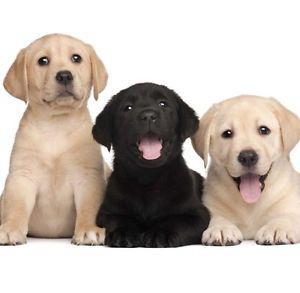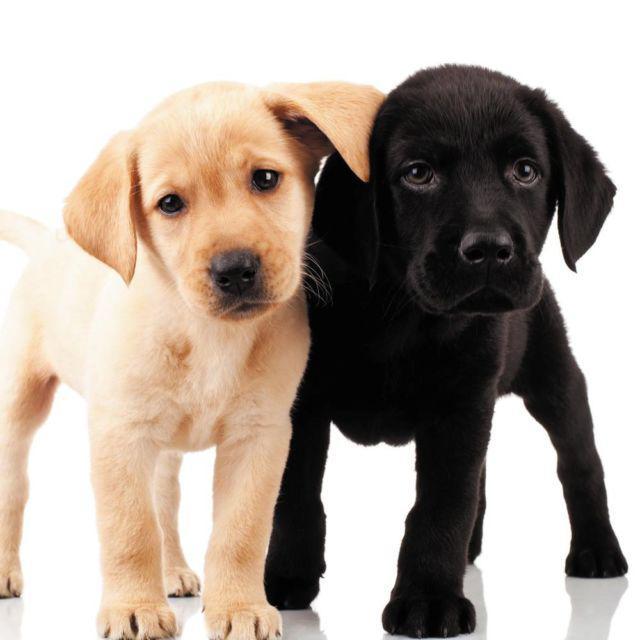The first image is the image on the left, the second image is the image on the right. Given the left and right images, does the statement "There are no more than five dogs" hold true? Answer yes or no. Yes. 